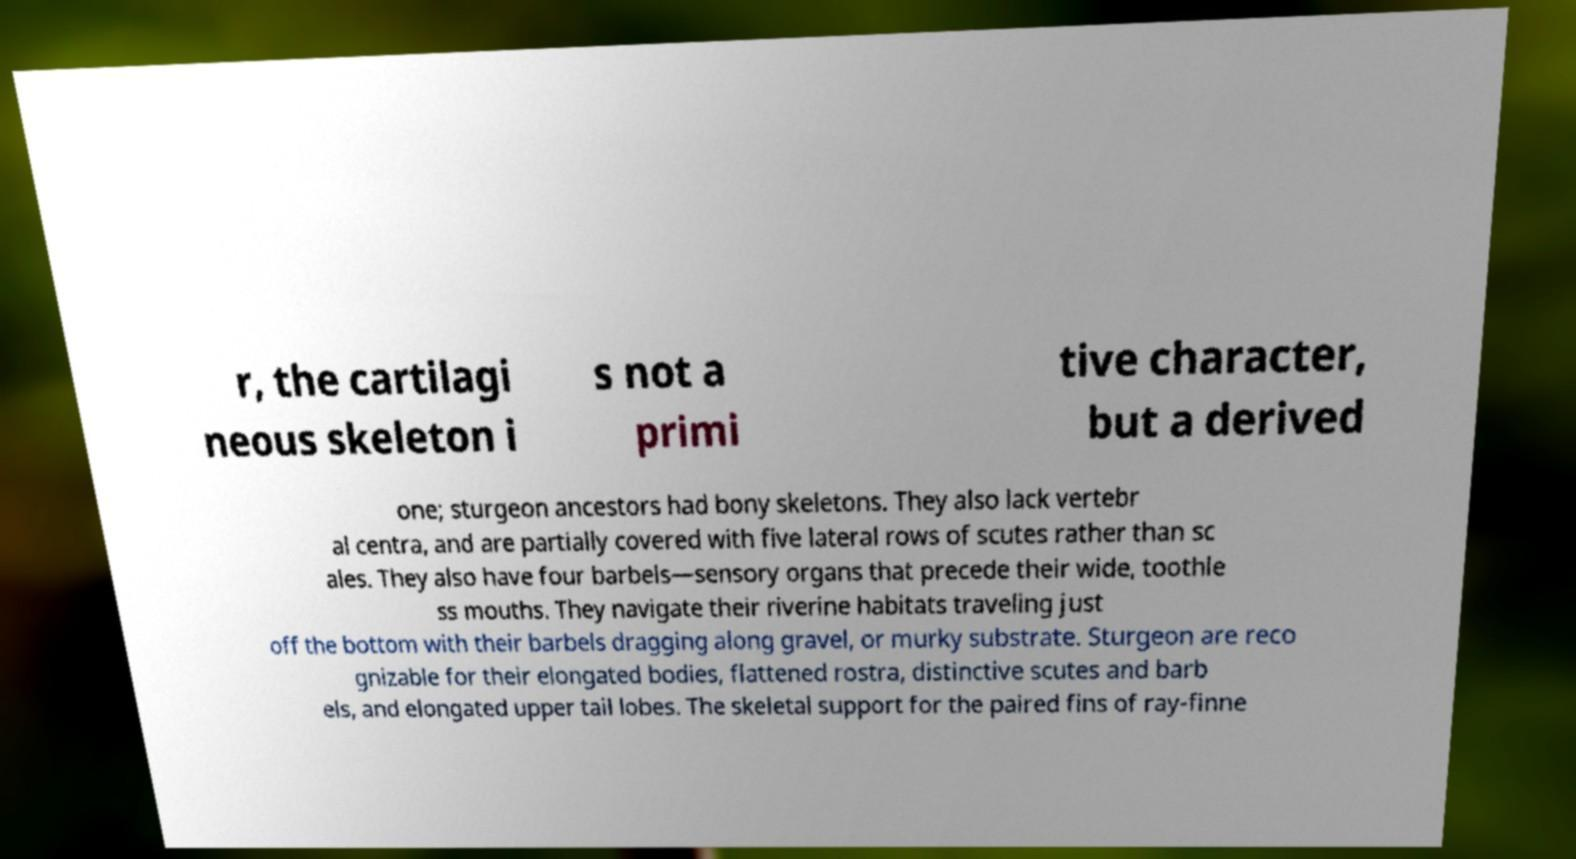Can you read and provide the text displayed in the image?This photo seems to have some interesting text. Can you extract and type it out for me? r, the cartilagi neous skeleton i s not a primi tive character, but a derived one; sturgeon ancestors had bony skeletons. They also lack vertebr al centra, and are partially covered with five lateral rows of scutes rather than sc ales. They also have four barbels—sensory organs that precede their wide, toothle ss mouths. They navigate their riverine habitats traveling just off the bottom with their barbels dragging along gravel, or murky substrate. Sturgeon are reco gnizable for their elongated bodies, flattened rostra, distinctive scutes and barb els, and elongated upper tail lobes. The skeletal support for the paired fins of ray-finne 